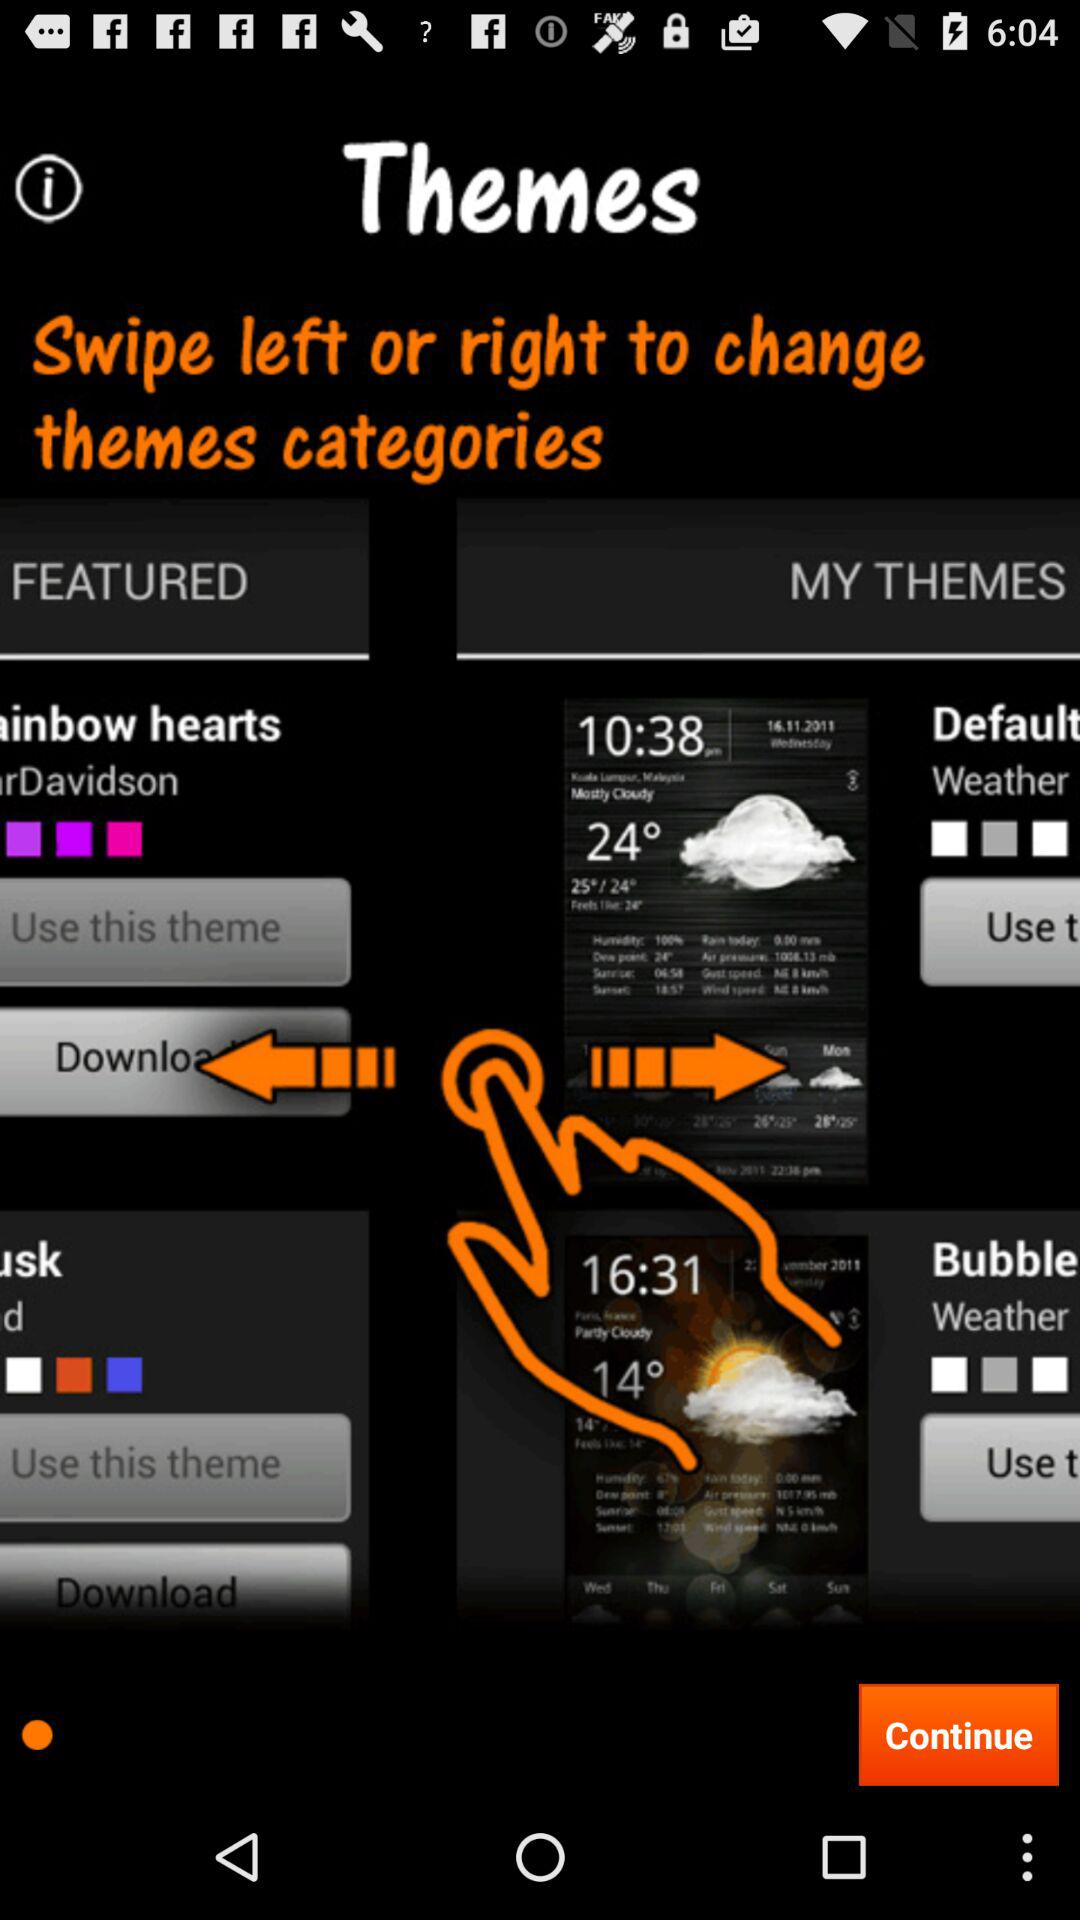What is the weather on 14.11.2011? The weather is mostly cloudy. 